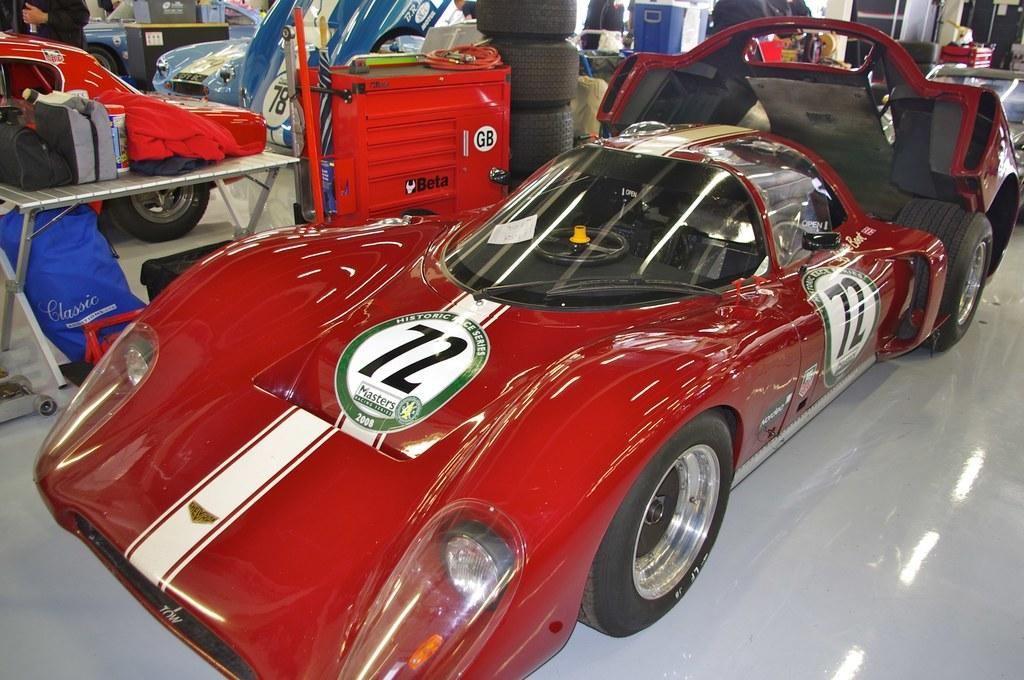What types of objects are present on the floor in the image? There are vehicles on the floor in the image. What part of the vehicles can be seen in the image? Tires are visible in the image. What type of furniture is present in the image? There are tables in the image. What else can be seen in the image besides vehicles and tables? There are objects and people in the image. What flavor of crayon is being used by the people in the image? There is no crayon present in the image, and therefore no flavor can be determined. 